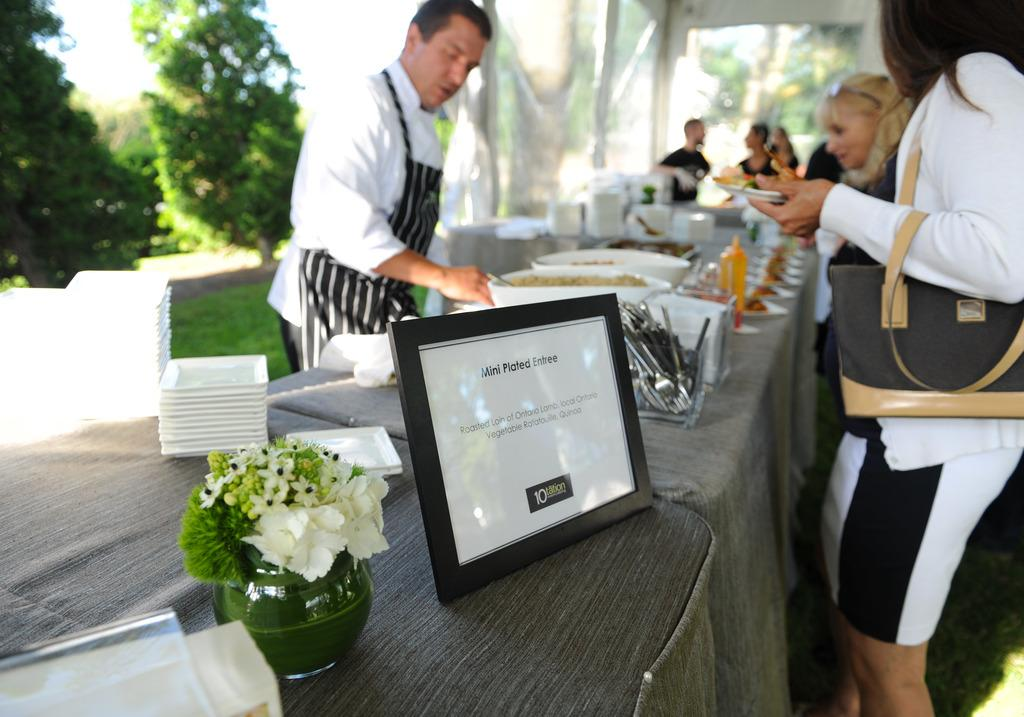How many people can be seen in the image? There are persons standing in the image. What type of vegetation is visible in the distance? There are trees in the distance. What is the ground surface like in the image? There is grass visible in the image. What type of furniture is present in the image? There is a table in the image. What is on the table? There is a bowl, plates, a plant, spoons, and a bottle on the table. What is the woman holding in the image? The woman is holding a plate. What accessory is the woman wearing? The woman is wearing a handbag. What type of basket is being used to collect the current in the image? There is no basket or current present in the image. 